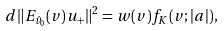<formula> <loc_0><loc_0><loc_500><loc_500>d \| E _ { \hat { v } _ { 0 } } ( v ) u _ { + } \| ^ { 2 } = w ( v ) f _ { K } ( v ; | a | ) ,</formula> 